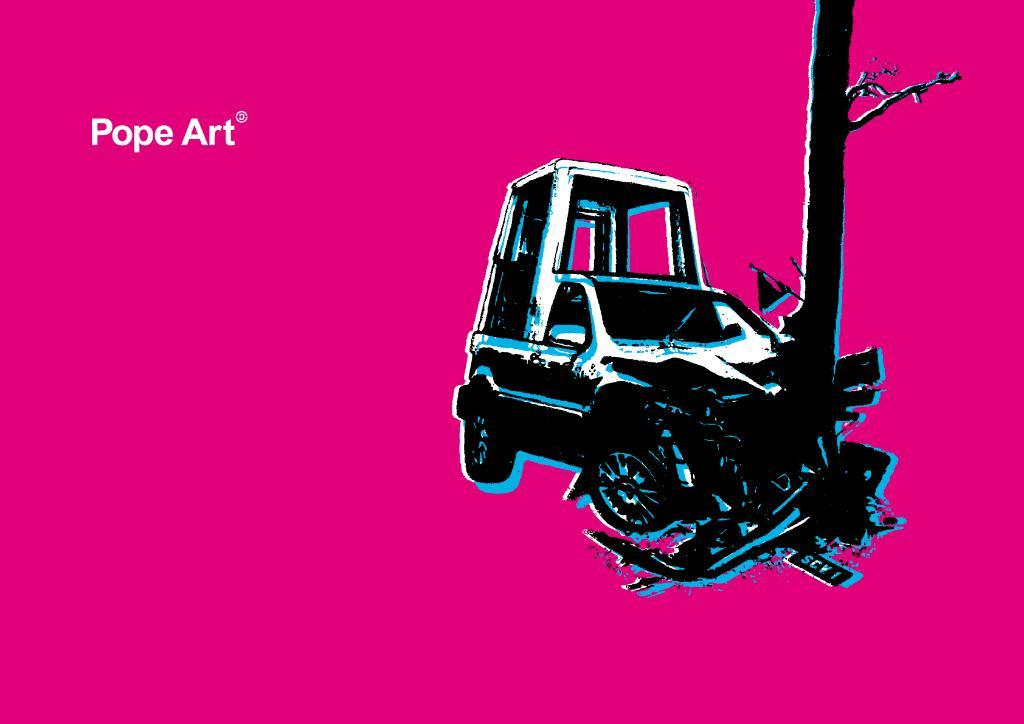What can be seen on the poster in the image? Unfortunately, the facts provided do not give any details about the poster's content. What type of accident is depicted in the image? There is a vehicle involved in an accident in the image. What can be read or seen in terms of text in the image? There is some text visible in the image. What color is the chalk used to draw the accident scene in the image? There is no chalk present in the image, as it is a photograph or digital representation of the scene. 